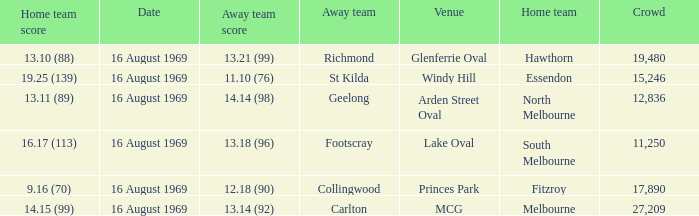What was the away team's score at Princes Park? 12.18 (90). 